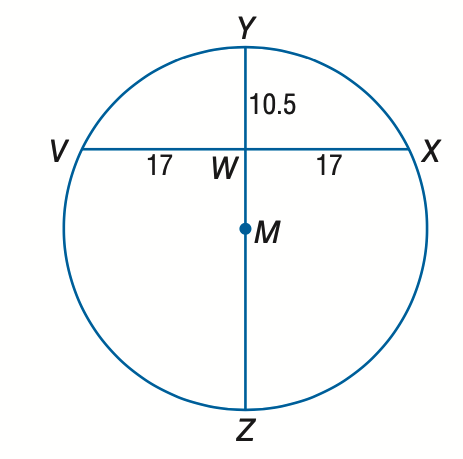Answer the mathemtical geometry problem and directly provide the correct option letter.
Question: Find the diameter of circle M.
Choices: A: 10.5 B: 27.5 C: 38.0 D: 42.5 C 